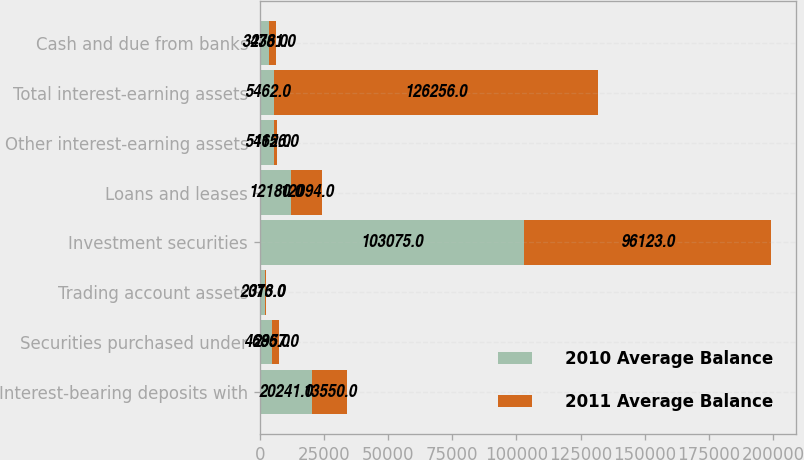Convert chart. <chart><loc_0><loc_0><loc_500><loc_500><stacked_bar_chart><ecel><fcel>Interest-bearing deposits with<fcel>Securities purchased under<fcel>Trading account assets<fcel>Investment securities<fcel>Loans and leases<fcel>Other interest-earning assets<fcel>Total interest-earning assets<fcel>Cash and due from banks<nl><fcel>2010 Average Balance<fcel>20241<fcel>4686<fcel>2013<fcel>103075<fcel>12180<fcel>5462<fcel>5462<fcel>3436<nl><fcel>2011 Average Balance<fcel>13550<fcel>2957<fcel>376<fcel>96123<fcel>12094<fcel>1156<fcel>126256<fcel>2781<nl></chart> 